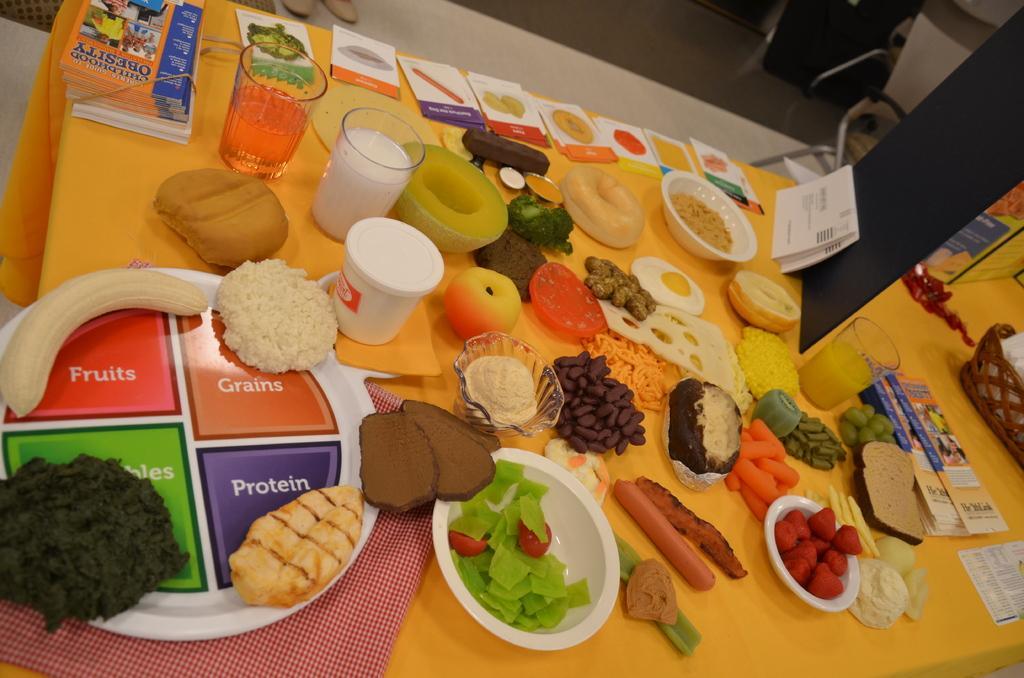In one or two sentences, can you explain what this image depicts? In this image, we can see a table covered with a cloth. This table contains glasses, bowls, papers and some food items. 